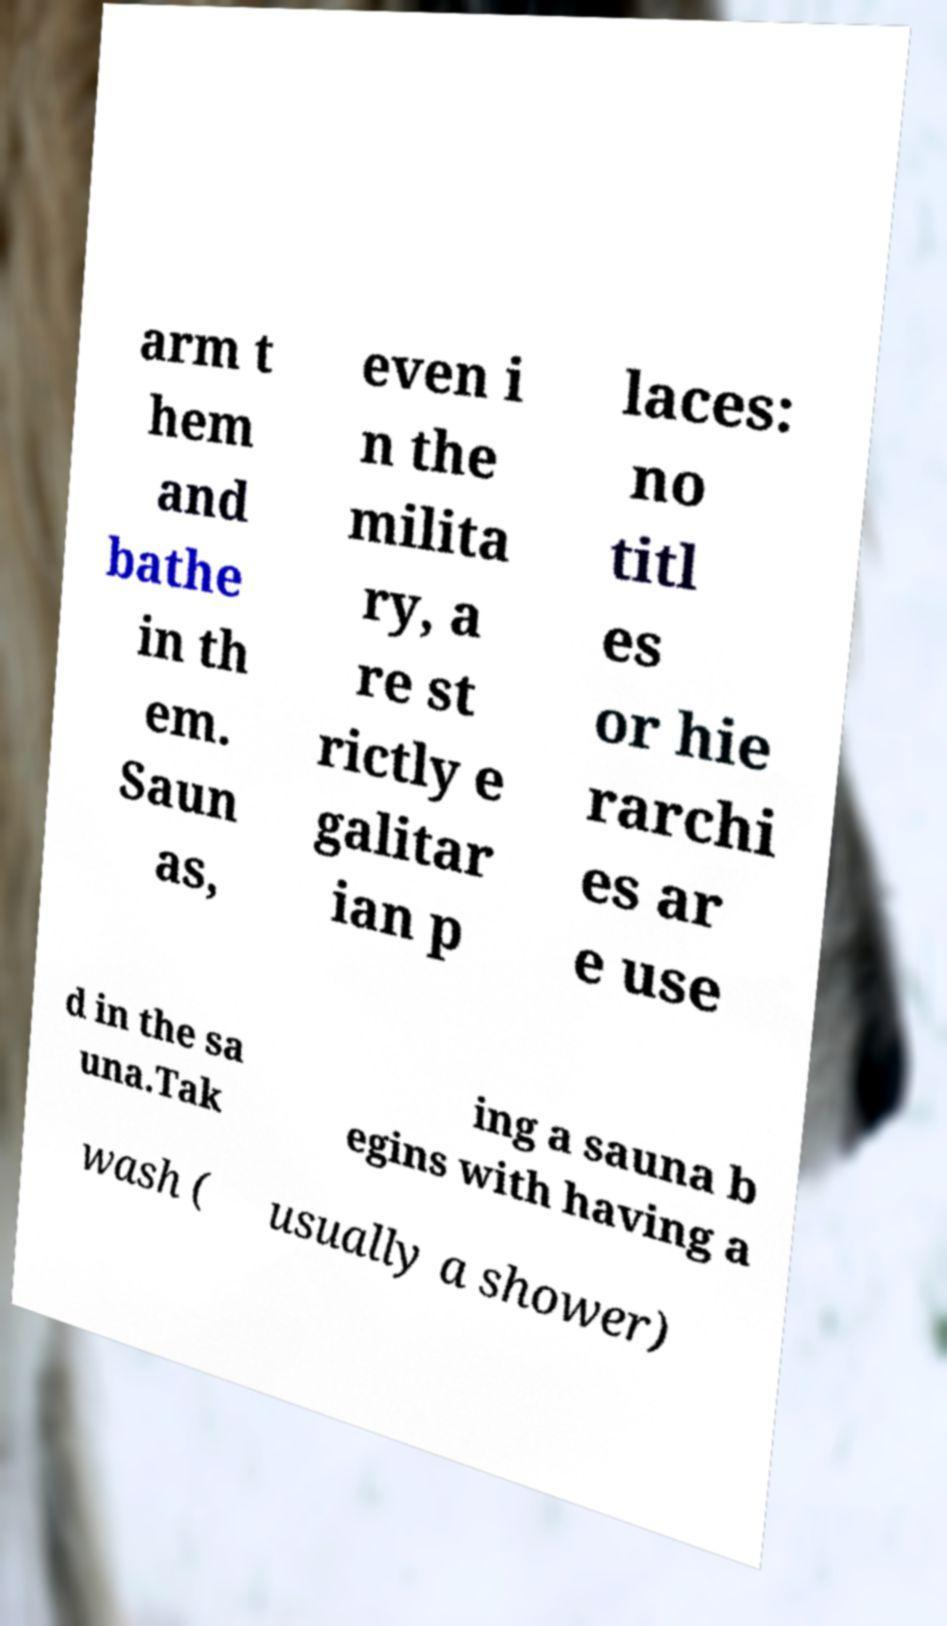For documentation purposes, I need the text within this image transcribed. Could you provide that? arm t hem and bathe in th em. Saun as, even i n the milita ry, a re st rictly e galitar ian p laces: no titl es or hie rarchi es ar e use d in the sa una.Tak ing a sauna b egins with having a wash ( usually a shower) 